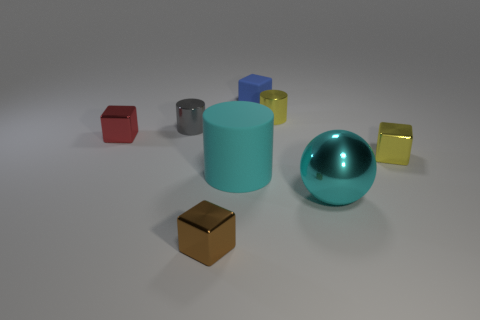The big rubber thing that is the same color as the big shiny thing is what shape?
Offer a terse response. Cylinder. There is a cylinder that is behind the gray shiny thing that is to the left of the small rubber cube; what is its material?
Offer a terse response. Metal. Are there any big cylinders of the same color as the large metal object?
Provide a short and direct response. Yes. What is the size of the object that is the same material as the big cyan cylinder?
Make the answer very short. Small. Are there any other things of the same color as the large metal sphere?
Offer a very short reply. Yes. There is a cylinder that is in front of the red shiny cube; what color is it?
Your response must be concise. Cyan. There is a brown metal thing that is on the left side of the tiny metallic cylinder behind the gray shiny cylinder; is there a red cube that is on the right side of it?
Give a very brief answer. No. Is the number of small cylinders right of the tiny blue rubber cube greater than the number of brown matte cubes?
Offer a very short reply. Yes. There is a yellow metal thing that is to the left of the cyan metal ball; is it the same shape as the small gray thing?
Offer a very short reply. Yes. How many objects are cyan metal spheres or metallic cylinders that are behind the big metallic sphere?
Ensure brevity in your answer.  3. 